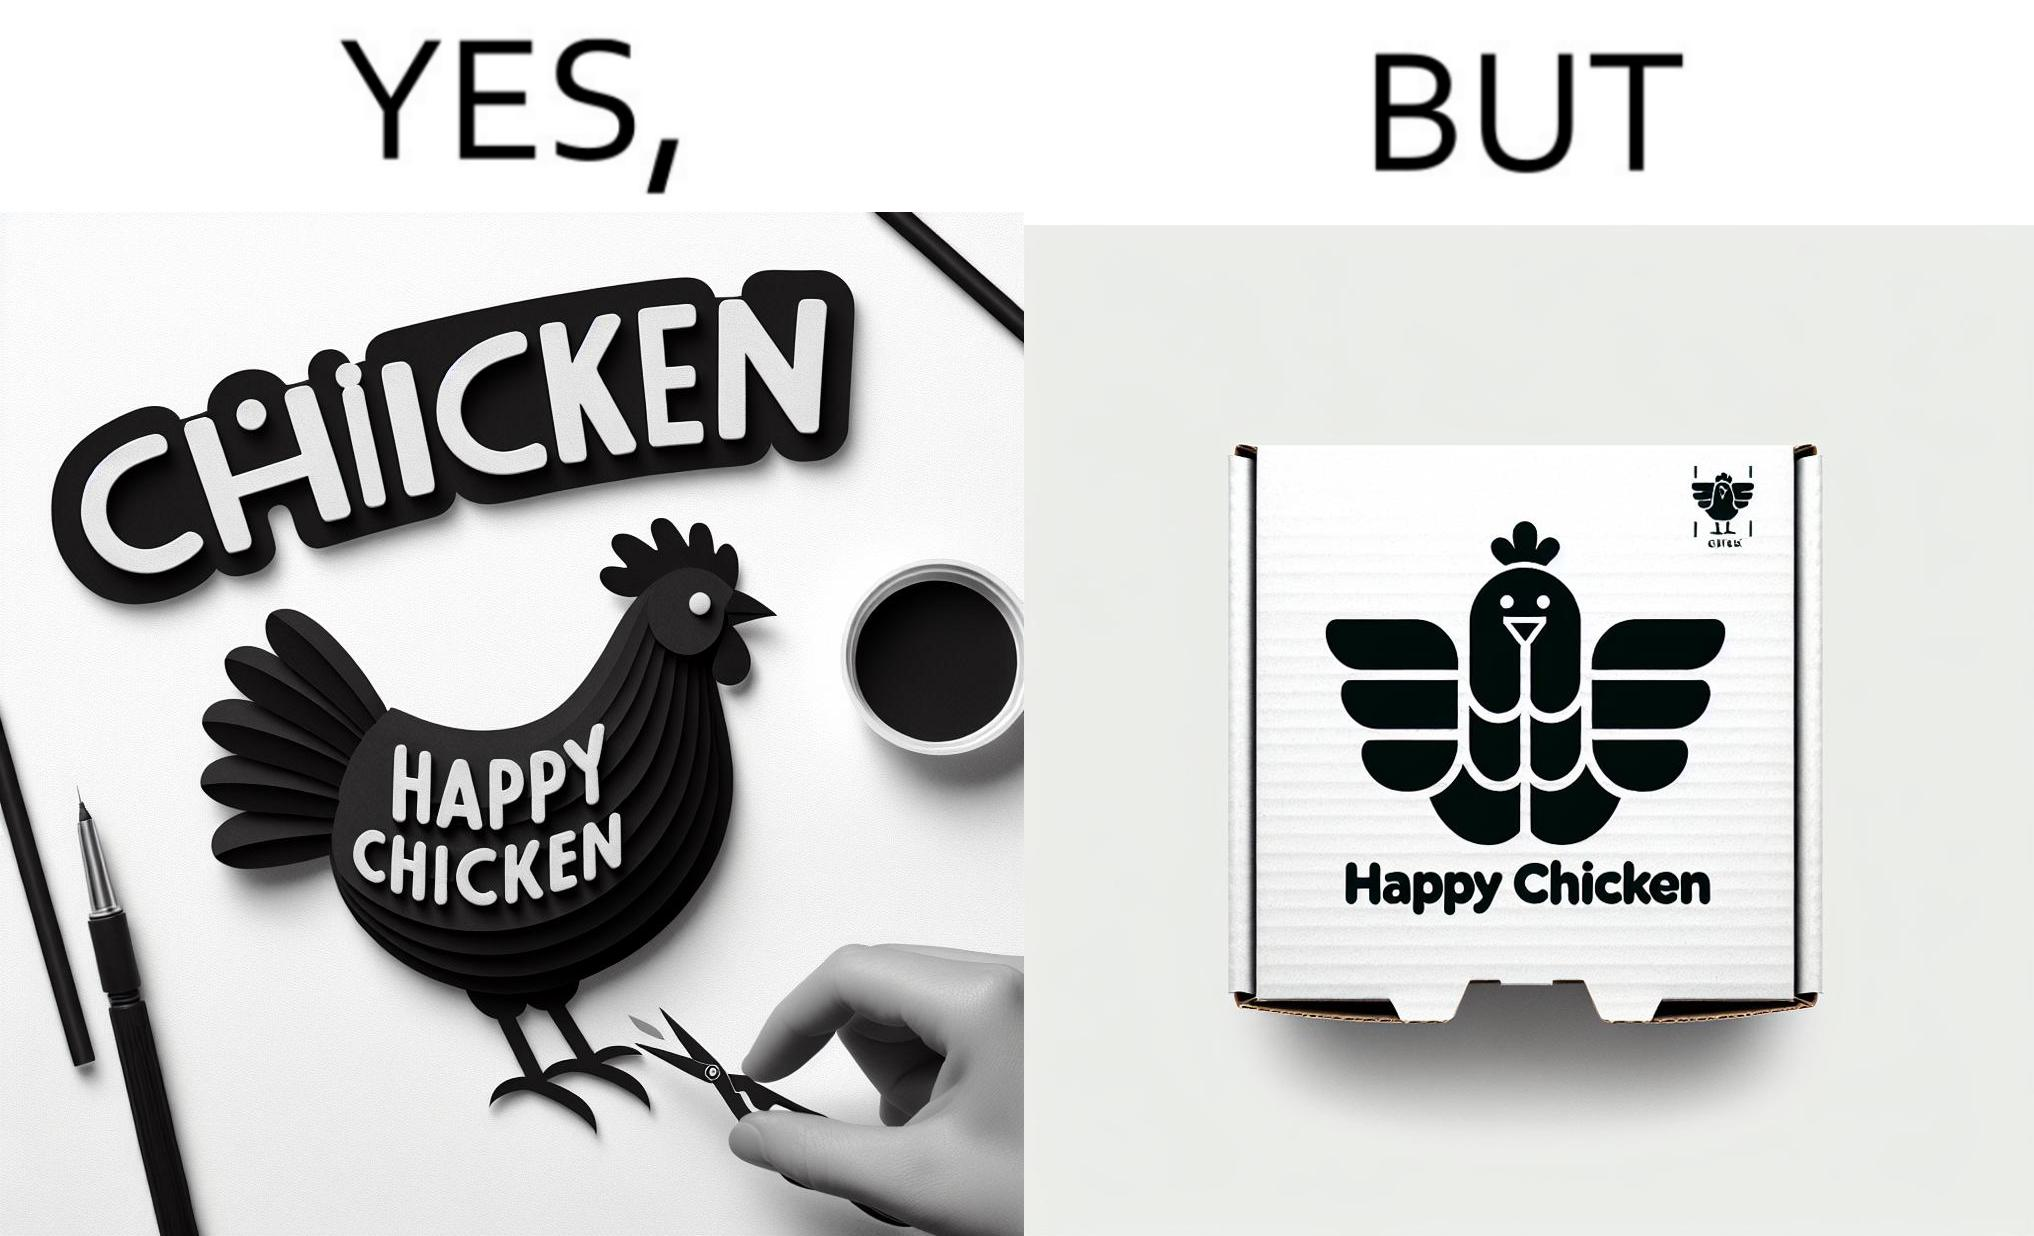Is there satirical content in this image? Yes, this image is satirical. 